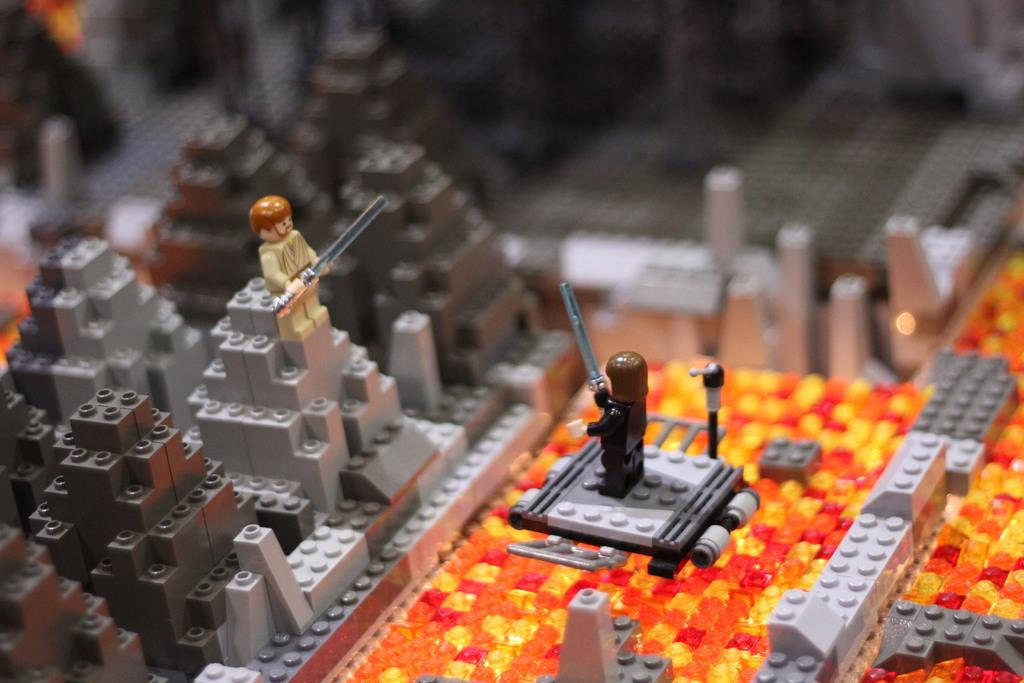What type of objects are in the image? There are legos in the image. Can you describe the legos in the image? The legos are small, plastic building blocks. What type of shoe can be seen in the image? There is no shoe present in the image; it features legos. Can you tell me how many robins are visible in the image? There are no robins present in the image; it features legos. 